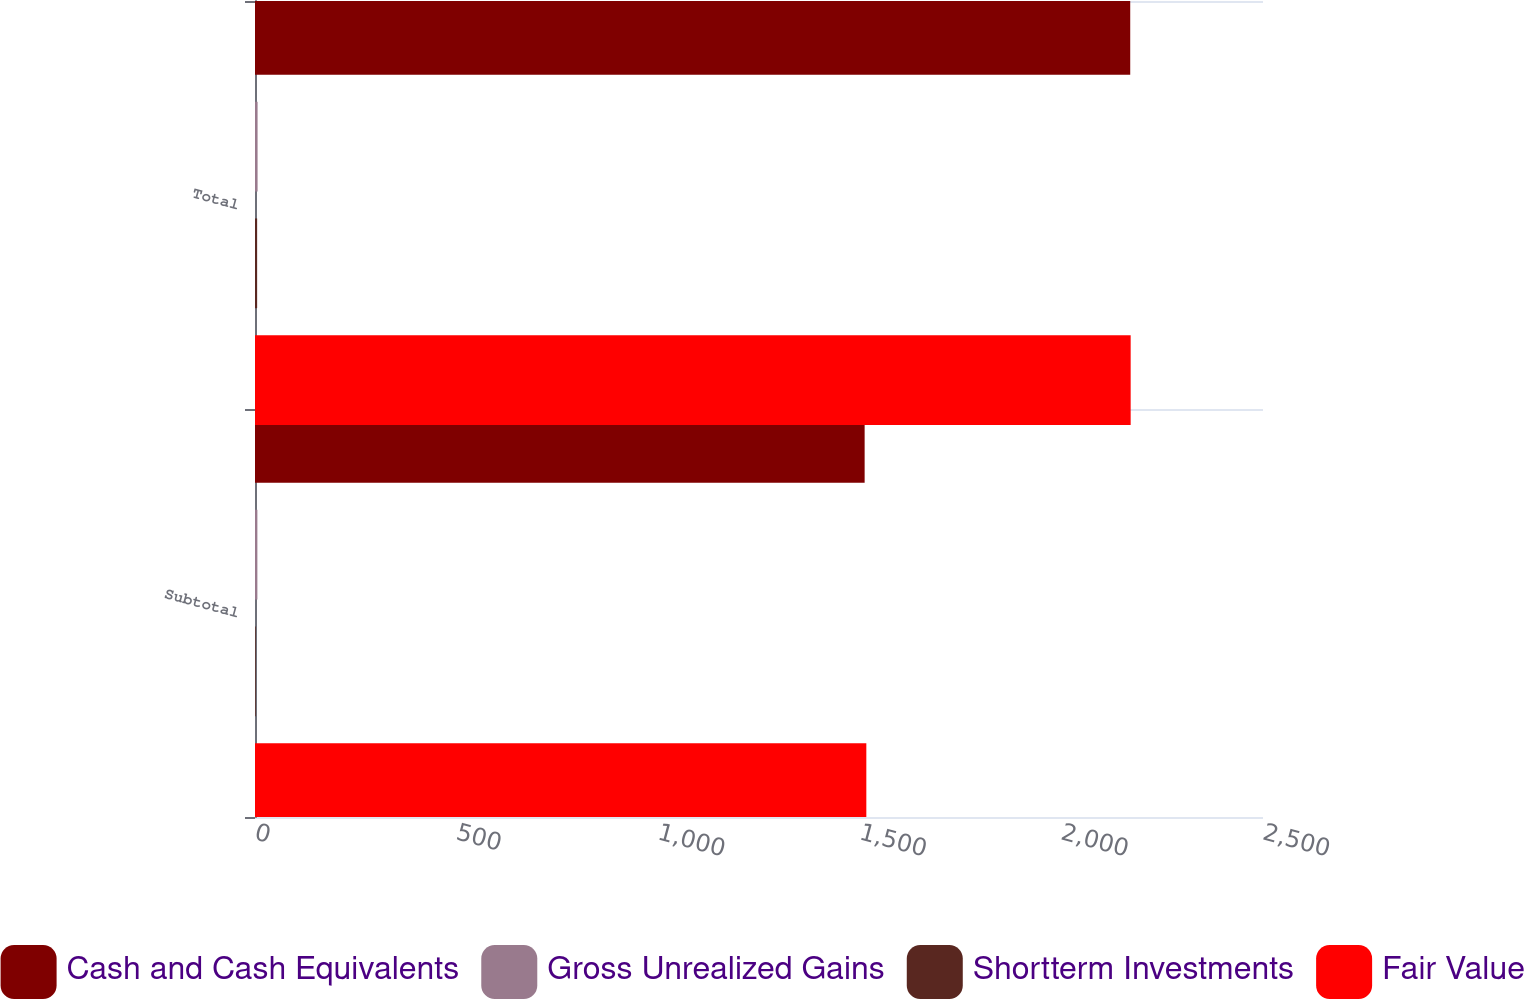Convert chart. <chart><loc_0><loc_0><loc_500><loc_500><stacked_bar_chart><ecel><fcel>Subtotal<fcel>Total<nl><fcel>Cash and Cash Equivalents<fcel>1512<fcel>2170.7<nl><fcel>Gross Unrealized Gains<fcel>5.9<fcel>6.4<nl><fcel>Shortterm Investments<fcel>1.7<fcel>5.3<nl><fcel>Fair Value<fcel>1516.2<fcel>2171.8<nl></chart> 